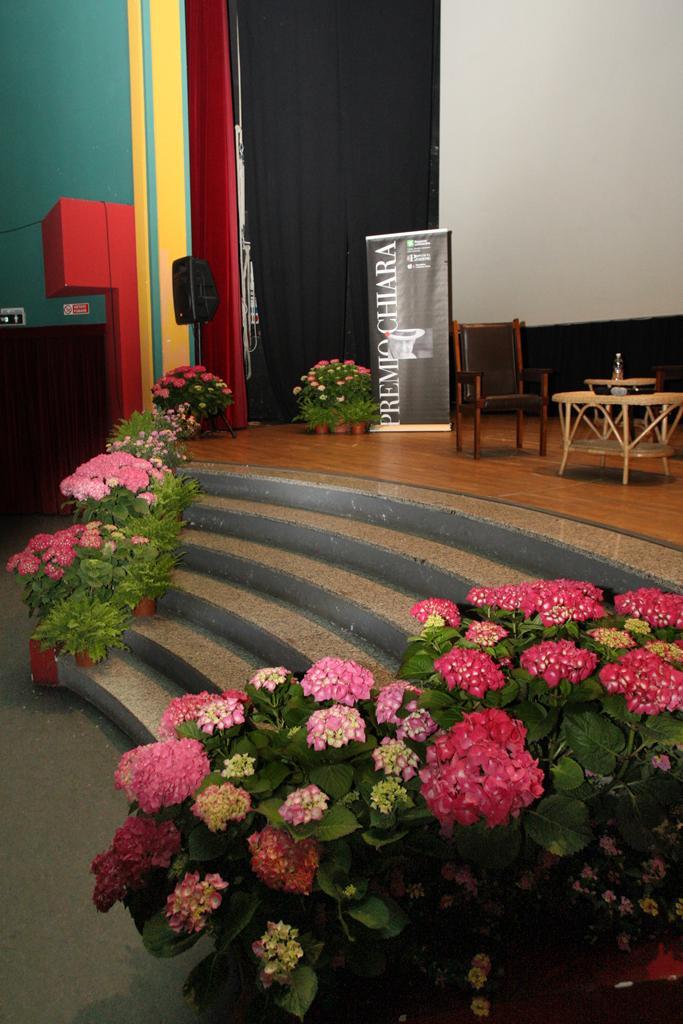Please provide a concise description of this image. In the image I can see few flower pots and colorful flowers. I can see stairs, banners, chairs, table, screen, black color curtains, few objects and the wall. 